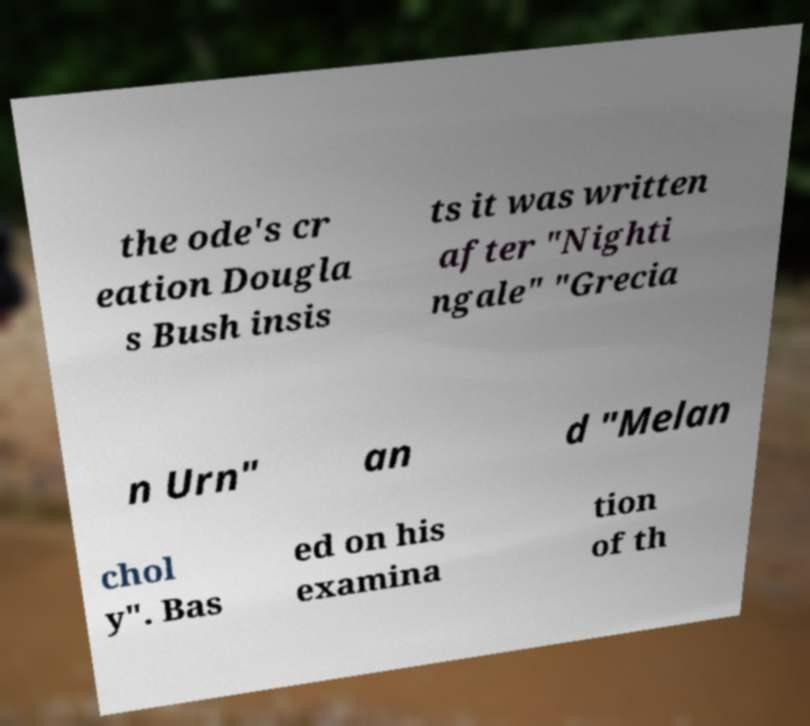What messages or text are displayed in this image? I need them in a readable, typed format. the ode's cr eation Dougla s Bush insis ts it was written after "Nighti ngale" "Grecia n Urn" an d "Melan chol y". Bas ed on his examina tion of th 